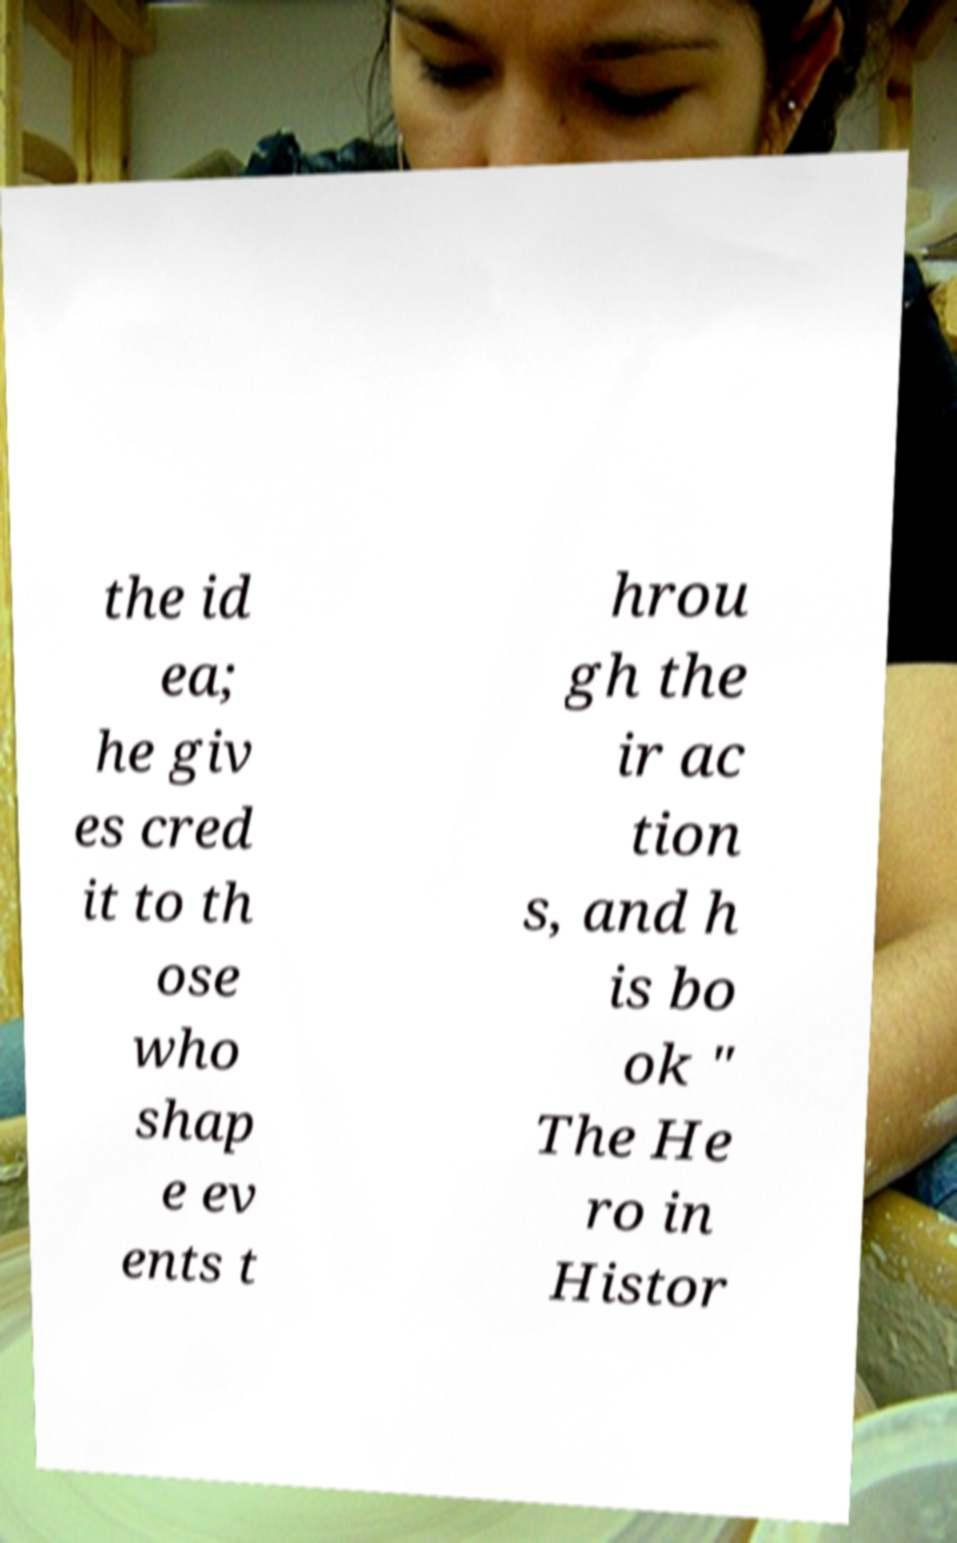What messages or text are displayed in this image? I need them in a readable, typed format. the id ea; he giv es cred it to th ose who shap e ev ents t hrou gh the ir ac tion s, and h is bo ok " The He ro in Histor 